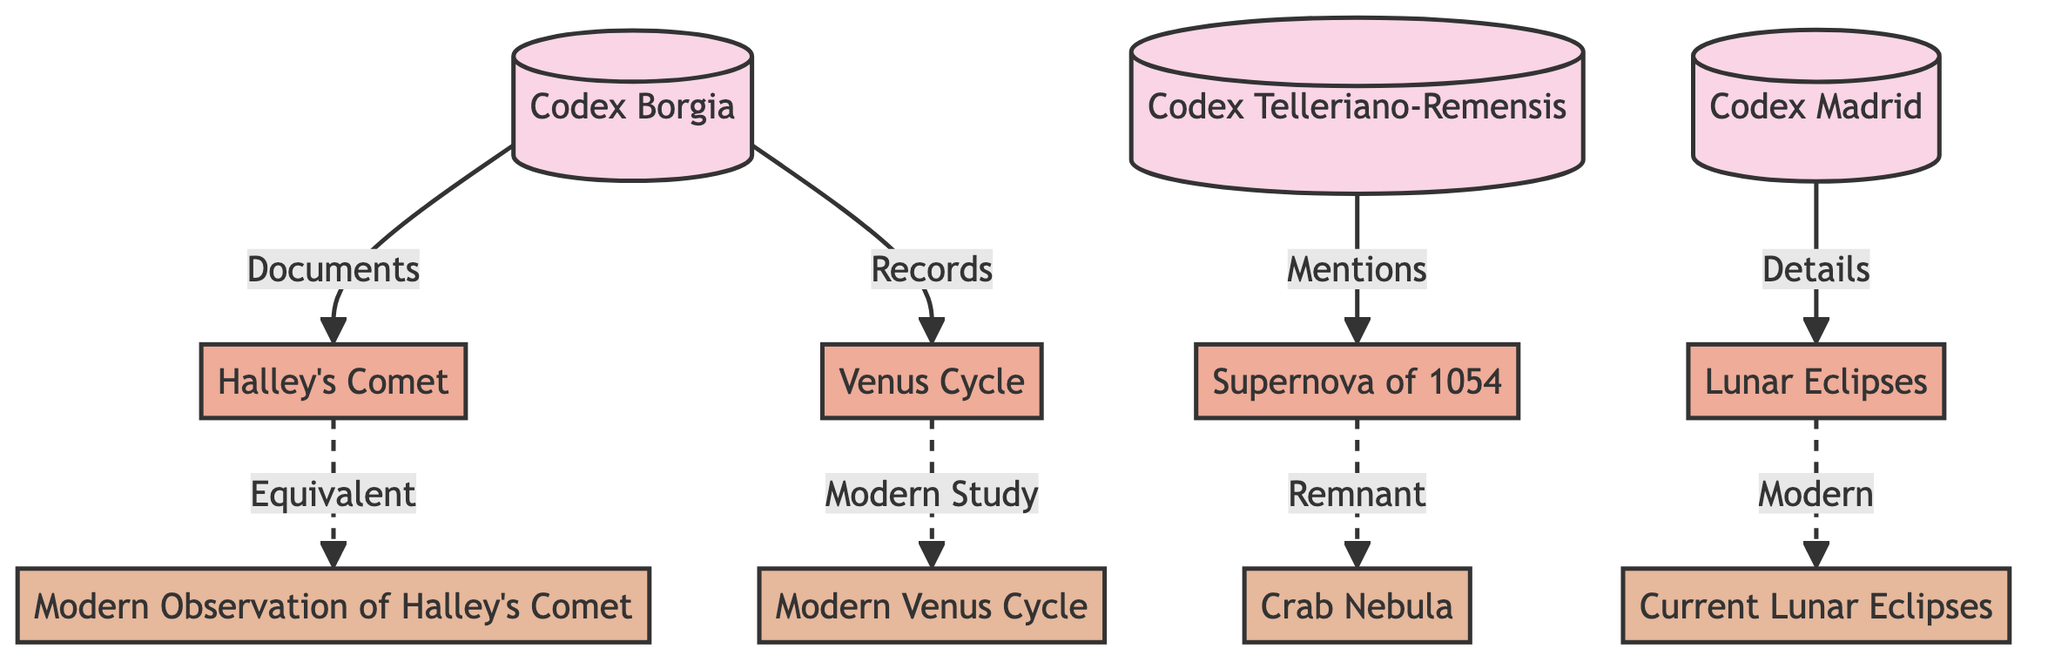What is the first codex mentioned in the diagram? The diagram shows "Codex Borgia" as the first codex listed at the top of the flowchart.
Answer: Codex Borgia How many celestial events are documented in the codices? There are four celestial events mentioned in the diagram: Halley's Comet, Supernova of 1054, Lunar Eclipses, and Venus Cycle, making a total of four events.
Answer: 4 Which codex details lunar eclipses? "Codex Madrid" is connected to "Lunar Eclipses," indicating it is the codex that details lunar eclipses.
Answer: Codex Madrid What modern observation corresponds to Halley's Comet? The diagram shows an equivalent connection from Halley's Comet to "Modern Observation of Halley's Comet."
Answer: Modern Observation of Halley's Comet Which celestial event has a modern counterpart labeled as a remnant? The "Supernova of 1054" has a modern counterpart labeled as "Crab Nebula," which is indicated by the dashed line.
Answer: Crab Nebula What type of relationship does "Codex Telleriano-Remensis" have with the supernova? The relationship is labeled "Mentions," indicating that the codex makes mention of the supernova.
Answer: Mentions How many modern events are there in this diagram? The diagram lists four modern events: Modern Observation of Halley's Comet, Crab Nebula, Current Lunar Eclipses, and Modern Venus Cycle, resulting in a total of four modern events.
Answer: 4 What is the link type between the Venus Cycle and its modern study? The connection is shown as a dashed line, labeled "Modern Study," indicating a less direct relationship compared to solid connections.
Answer: Modern Study What celestial event is recorded in "Codex Borgia"? The diagram shows that "Codex Borgia" documents "Halley's Comet," indicating that this event is recorded in that codex.
Answer: Halley's Comet 